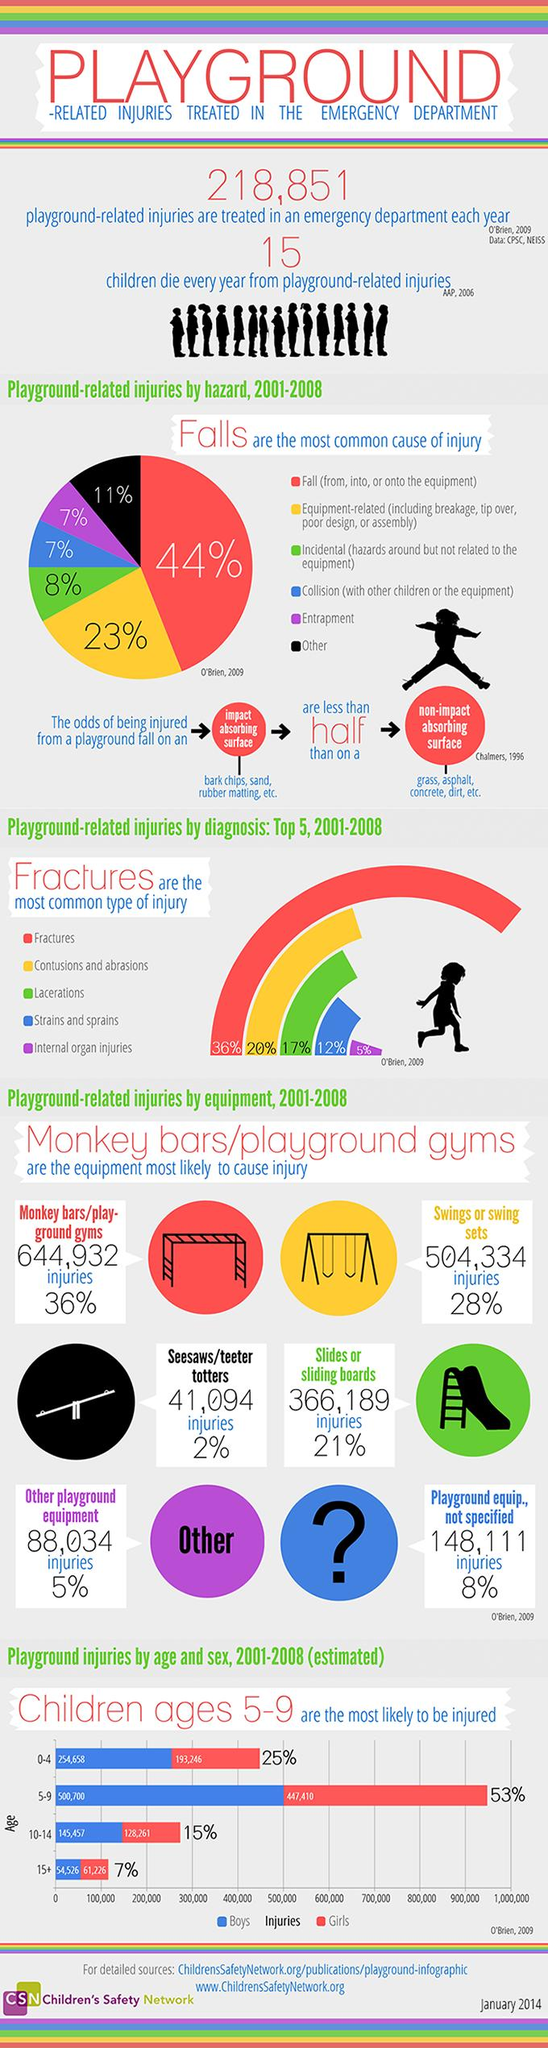Mention a couple of crucial points in this snapshot. According to reported injuries, swings or swing sets have resulted in 504,334 incidents. According to research, 20% of playground injuries involve contusions and abrasions. According to the data, a total of 366,189 injuries were reported due to slides or sliding boards. Approximately 36% of injuries sustained on playgrounds are a result of fractures. According to our study, 36% of injuries occurred on monkey bars or playground gyms. 